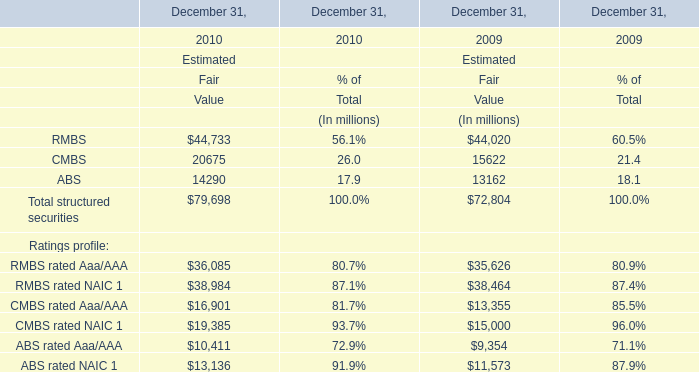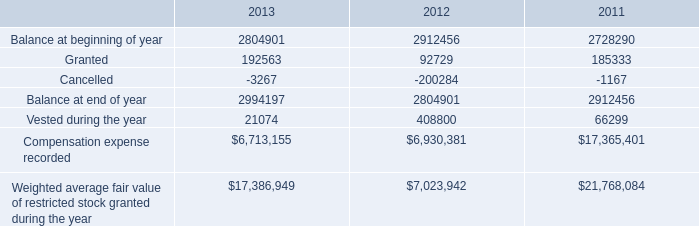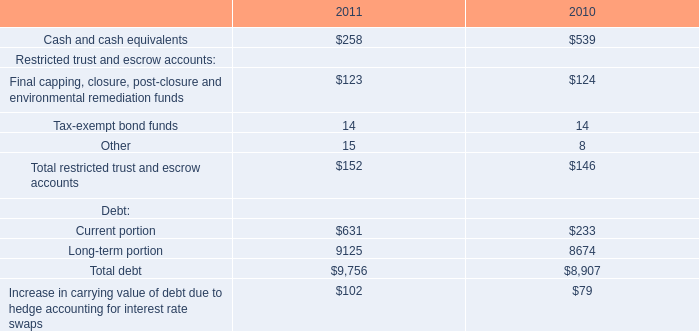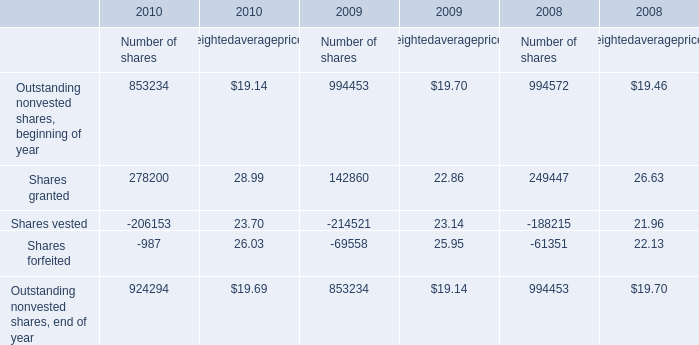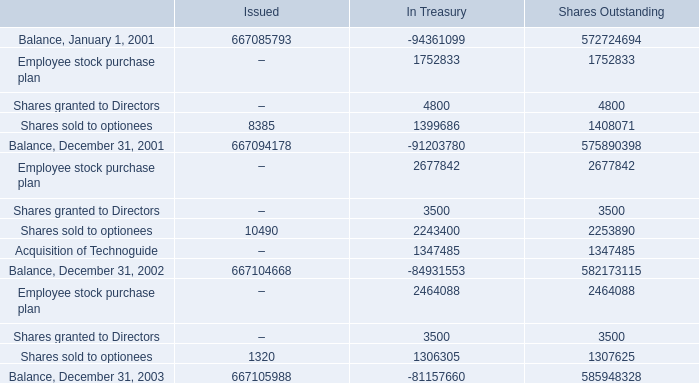What is the average amount of Employee stock purchase plan of Shares Outstanding, and Vested during the year of 2012 ? 
Computations: ((2677842.0 + 408800.0) / 2)
Answer: 1543321.0. 